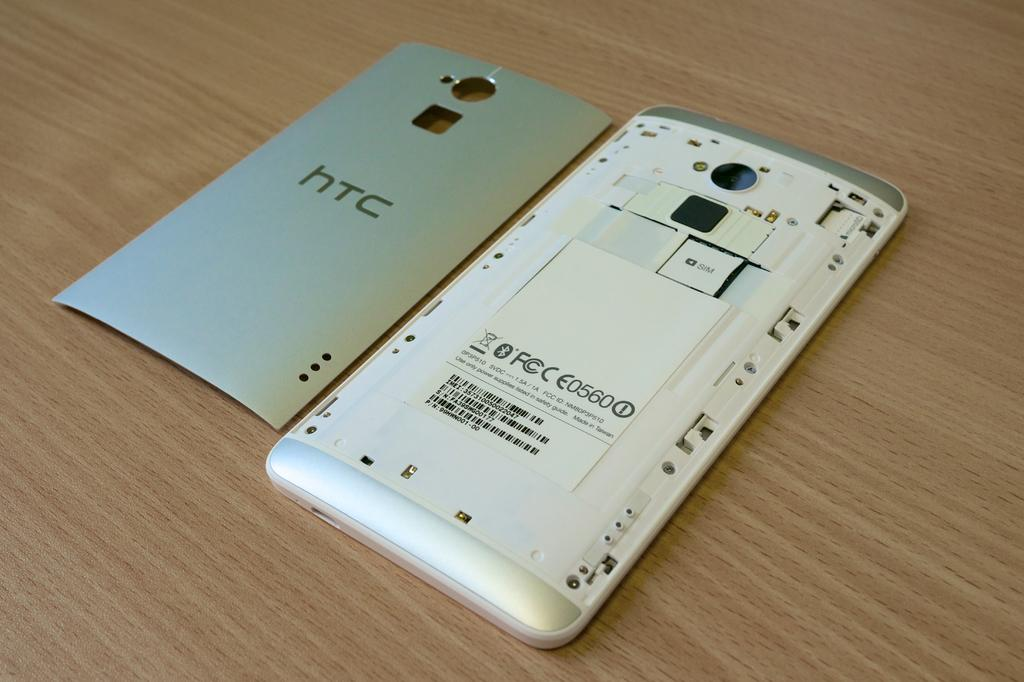What electronic device is on the table in the image? There is a cell phone on the table in the image. What accessory is located beside the cell phone? There is a cell phone cover beside the cell phone. What type of brick is being used to create a point in the image? There is no brick or point present in the image; it features a cell phone and a cell phone cover on a table. 